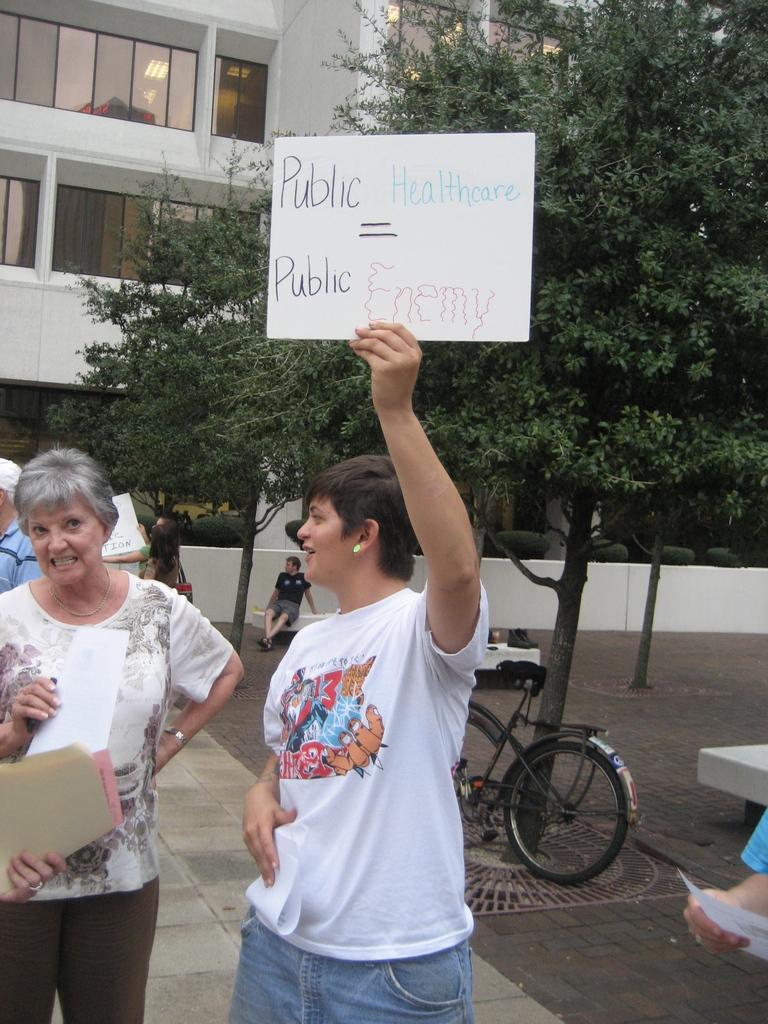How would you summarize this image in a sentence or two? Here in this picture we can see some people standing on the ground and the woman in the middle is holding a placard in her hand and smiling and all other people are also holding some papers in their hands and behind them we can see a bicycle present and we can also see trees present on the ground and we can also see building with number of windows on it present over there. 